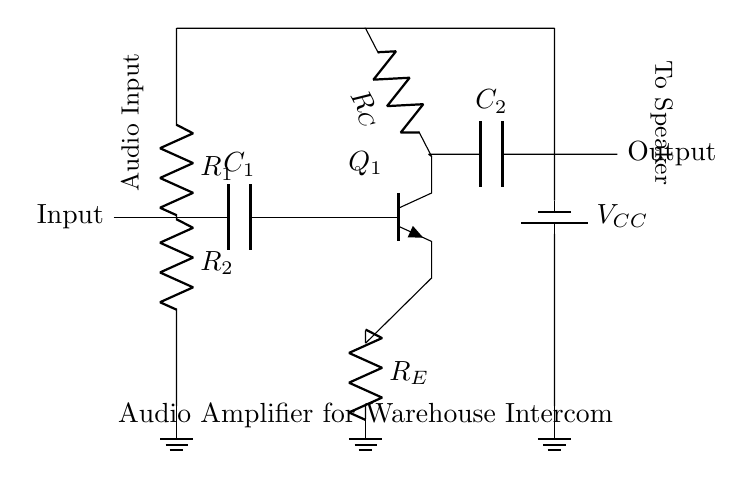what is the input component in this circuit? The input component is a capacitor labeled C1, which couples the audio signal into the circuit.
Answer: capacitor C1 what type of transistor is used in this amplifier? The amplifier circuit uses an NPN transistor, as indicated by the symbol and notation in the diagram.
Answer: NPN what is the value of the resistor connected to the emitter? The resistor connected to the emitter is labeled RE, which is the only component mentioned without a specific resistance value assigned in the diagram.
Answer: resistor RE what is the purpose of capacitor C2 in the circuit? Capacitor C2 functions as a coupling capacitor, allowing the AC audio signal to pass while blocking any DC components from reaching the output.
Answer: coupling how many resistors are present in this circuit? There are three resistors in the circuit: RE, RC, and R1, R2, which makes a total of four resistors.
Answer: four what voltage does the power supply provide? The voltage provided by the power supply is indicated by VCC, but the exact value is not specified in the circuit diagram.
Answer: VCC what is the output node labeled in the circuit? The output node is labeled as "Output," showing where the amplified audio signal is sent to the speaker.
Answer: Output 